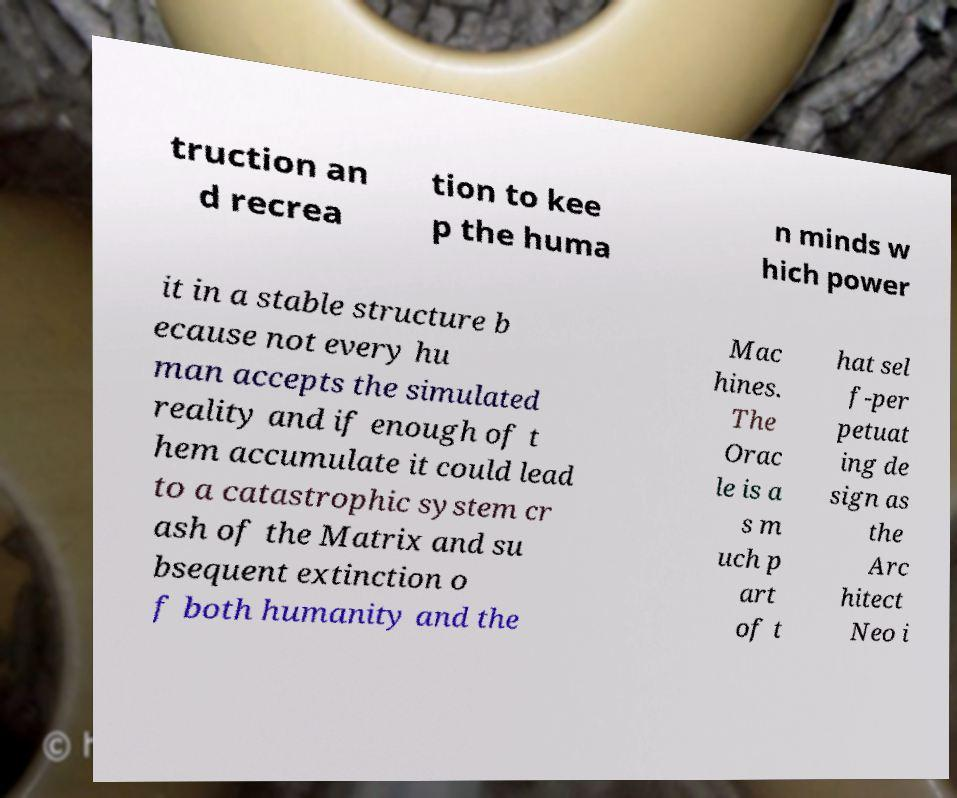Can you read and provide the text displayed in the image?This photo seems to have some interesting text. Can you extract and type it out for me? truction an d recrea tion to kee p the huma n minds w hich power it in a stable structure b ecause not every hu man accepts the simulated reality and if enough of t hem accumulate it could lead to a catastrophic system cr ash of the Matrix and su bsequent extinction o f both humanity and the Mac hines. The Orac le is a s m uch p art of t hat sel f-per petuat ing de sign as the Arc hitect Neo i 